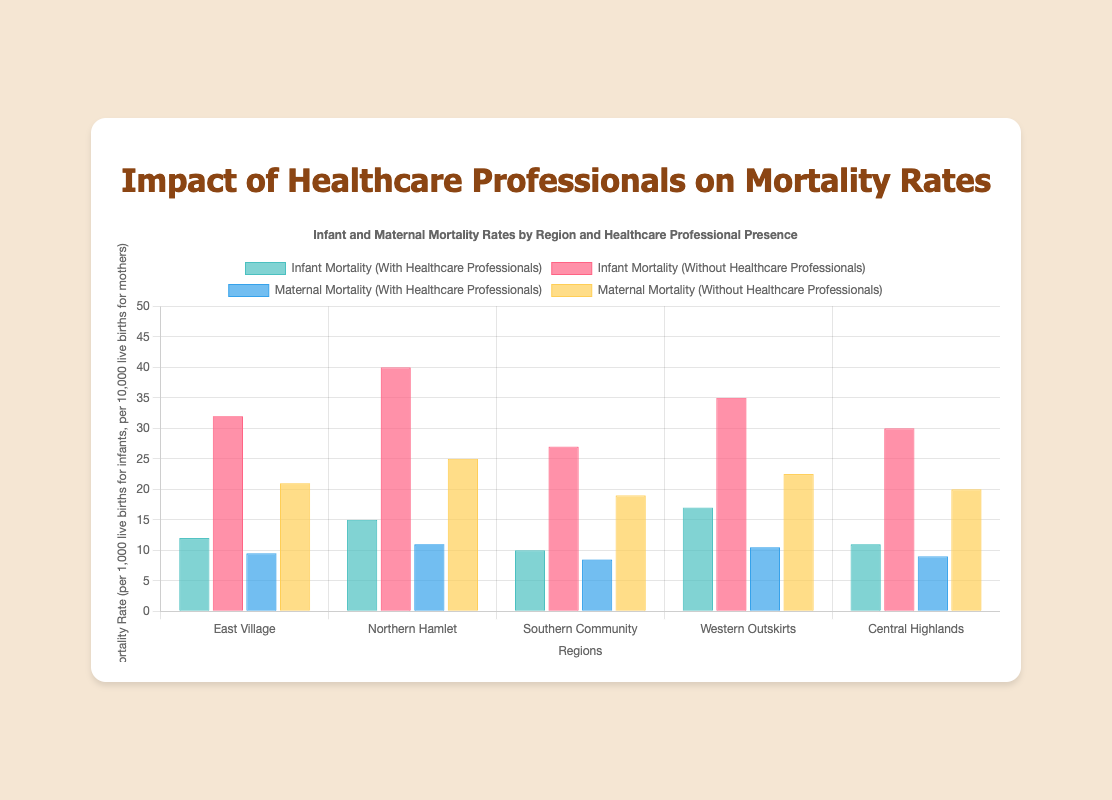Which region has the lowest infant mortality rate with the presence of trained healthcare professionals? By comparing the bars representing infant mortality rates with the presence of trained healthcare professionals, we see that "Southern Community" has the lowest rate of 10 per 1000 live births.
Answer: Southern Community Which region shows the highest maternal mortality rate without the presence of trained healthcare professionals? By examining the bars representing maternal mortality rates without trained healthcare professionals, "Northern Hamlet" has the highest rate of 250 per 100000 live births.
Answer: Northern Hamlet What is the difference in infant mortality rates between the presence and absence of trained healthcare professionals in Western Outskirts? The infant mortality rates in Western Outskirts are 17 per 1000 live births with healthcare professionals and 35 per 1000 live births without them. The difference is 35 - 17 = 18.
Answer: 18 Compare the infant mortality rates in Northern Hamlet for the presence and absence of trained healthcare professionals. In Northern Hamlet, the rates are 15 per 1000 live births with healthcare professionals and 40 per 1000 live births without them. Thus, 40 is significantly higher than 15.
Answer: 40 is higher than 15 What is the combined maternal mortality rate (scaled down value) for Central Highlands with and without trained healthcare professionals? The maternal mortality rates are 9 (90/10) with healthcare professionals and 20 (200/10) without them. So, combined, it is 9 + 20 = 29.
Answer: 29 Which regions show a greater than 20 difference in maternal mortality rates between the presence and absence of trained healthcare professionals? We calculate the differences for each region: East Village: 21, Northern Hamlet: 14, Southern Community: 10.5, Western Outskirts: 12, Central Highlands: 11. The regions "East Village" show more than 20 differences.
Answer: East Village In which regions is the infant mortality rate exactly half when healthcare professionals are present compared to when they are not? We compare: East Village (12 vs 32), Northern Hamlet (15 vs 40), Southern Community (10 vs 27), Western Outskirts (17 vs 35), Central Highlands (11 vs 30). None is exactly half.
Answer: None If we average the infant mortality rates with the presence of trained healthcare professionals in all regions, what would the value be? The rates are 12, 15, 10, 17, 11. Summing these gives 65. Dividing by 5 regions, the average is 65/5 = 13.
Answer: 13 